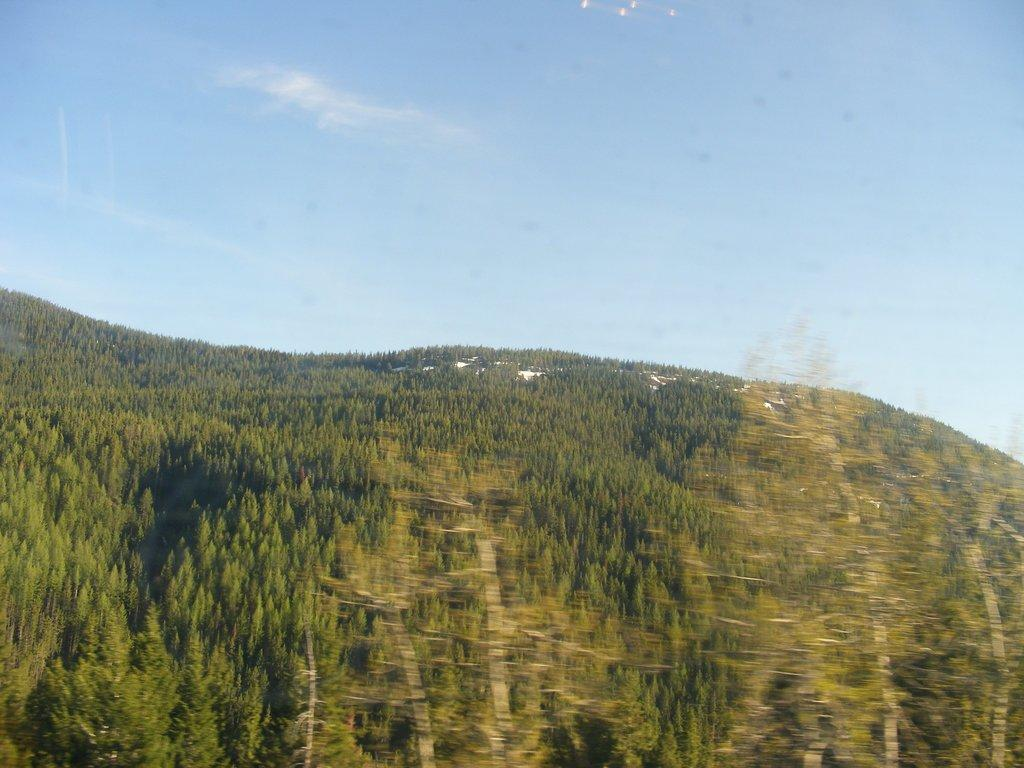What is the main feature of the image? There is a large group of trees on a hill in the image. What else can be seen in the image besides the trees? The sky is visible in the image. How would you describe the sky in the image? The sky appears to be cloudy. How many pizzas are being eaten by the bears under the trees in the image? There are no bears or pizzas present in the image; it features a large group of trees on a hill with a cloudy sky. 